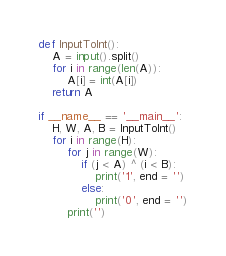<code> <loc_0><loc_0><loc_500><loc_500><_Python_>def InputToInt():
    A = input().split()
    for i in range(len(A)):
        A[i] = int(A[i])
    return A
    
if __name__ == '__main__':
    H, W, A, B = InputToInt()
    for i in range(H):
        for j in range(W):
            if (j < A) ^ (i < B):
                print('1', end = '')
            else:
                print('0', end = '')
        print('')
</code> 